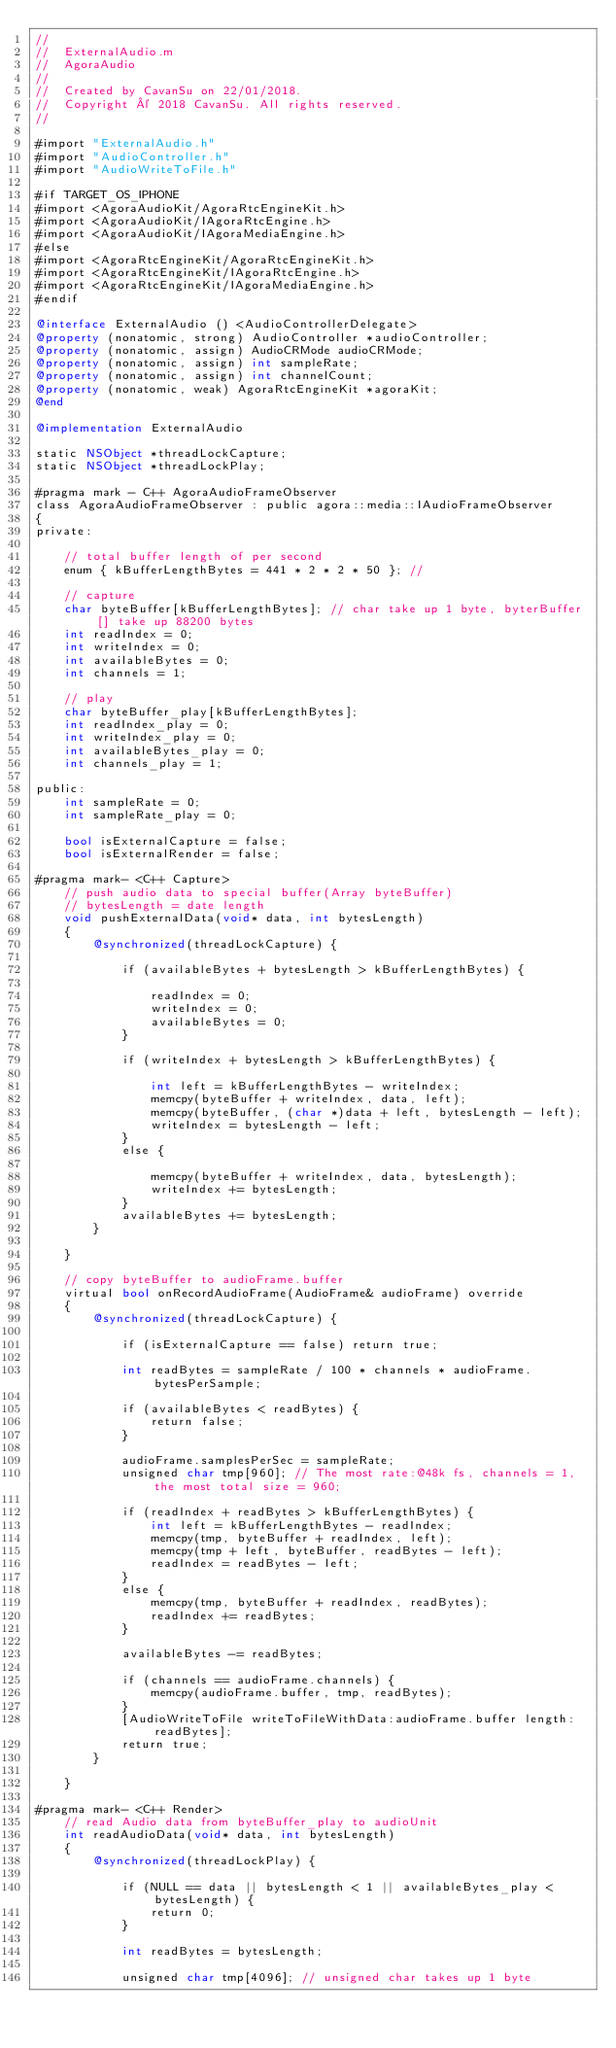Convert code to text. <code><loc_0><loc_0><loc_500><loc_500><_ObjectiveC_>//
//  ExternalAudio.m
//  AgoraAudio
//
//  Created by CavanSu on 22/01/2018.
//  Copyright © 2018 CavanSu. All rights reserved.
//

#import "ExternalAudio.h"
#import "AudioController.h"
#import "AudioWriteToFile.h"

#if TARGET_OS_IPHONE
#import <AgoraAudioKit/AgoraRtcEngineKit.h>
#import <AgoraAudioKit/IAgoraRtcEngine.h>
#import <AgoraAudioKit/IAgoraMediaEngine.h>
#else
#import <AgoraRtcEngineKit/AgoraRtcEngineKit.h>
#import <AgoraRtcEngineKit/IAgoraRtcEngine.h>
#import <AgoraRtcEngineKit/IAgoraMediaEngine.h>
#endif

@interface ExternalAudio () <AudioControllerDelegate>
@property (nonatomic, strong) AudioController *audioController;
@property (nonatomic, assign) AudioCRMode audioCRMode;
@property (nonatomic, assign) int sampleRate;
@property (nonatomic, assign) int channelCount;
@property (nonatomic, weak) AgoraRtcEngineKit *agoraKit;
@end

@implementation ExternalAudio

static NSObject *threadLockCapture;
static NSObject *threadLockPlay;

#pragma mark - C++ AgoraAudioFrameObserver
class AgoraAudioFrameObserver : public agora::media::IAudioFrameObserver
{
private:
    
    // total buffer length of per second
    enum { kBufferLengthBytes = 441 * 2 * 2 * 50 }; //
    
    // capture
    char byteBuffer[kBufferLengthBytes]; // char take up 1 byte, byterBuffer[] take up 88200 bytes
    int readIndex = 0;
    int writeIndex = 0;
    int availableBytes = 0;
    int channels = 1;
    
    // play
    char byteBuffer_play[kBufferLengthBytes];
    int readIndex_play = 0;
    int writeIndex_play = 0;
    int availableBytes_play = 0;
    int channels_play = 1;
    
public:
    int sampleRate = 0;
    int sampleRate_play = 0;
    
    bool isExternalCapture = false;
    bool isExternalRender = false;
    
#pragma mark- <C++ Capture>
    // push audio data to special buffer(Array byteBuffer)
    // bytesLength = date length
    void pushExternalData(void* data, int bytesLength)
    {
        @synchronized(threadLockCapture) {
            
            if (availableBytes + bytesLength > kBufferLengthBytes) {
                
                readIndex = 0;
                writeIndex = 0;
                availableBytes = 0;
            }
            
            if (writeIndex + bytesLength > kBufferLengthBytes) {
                
                int left = kBufferLengthBytes - writeIndex;
                memcpy(byteBuffer + writeIndex, data, left);
                memcpy(byteBuffer, (char *)data + left, bytesLength - left);
                writeIndex = bytesLength - left;
            }
            else {
                
                memcpy(byteBuffer + writeIndex, data, bytesLength);
                writeIndex += bytesLength;
            }
            availableBytes += bytesLength;
        }
    
    }
    
    // copy byteBuffer to audioFrame.buffer
    virtual bool onRecordAudioFrame(AudioFrame& audioFrame) override
    {
        @synchronized(threadLockCapture) {
            
            if (isExternalCapture == false) return true;
            
            int readBytes = sampleRate / 100 * channels * audioFrame.bytesPerSample;
            
            if (availableBytes < readBytes) {
                return false;
            }
            
            audioFrame.samplesPerSec = sampleRate;
            unsigned char tmp[960]; // The most rate:@48k fs, channels = 1, the most total size = 960;
            
            if (readIndex + readBytes > kBufferLengthBytes) {
                int left = kBufferLengthBytes - readIndex;
                memcpy(tmp, byteBuffer + readIndex, left);
                memcpy(tmp + left, byteBuffer, readBytes - left);
                readIndex = readBytes - left;
            }
            else {
                memcpy(tmp, byteBuffer + readIndex, readBytes);
                readIndex += readBytes;
            }
            
            availableBytes -= readBytes;
            
            if (channels == audioFrame.channels) {
                memcpy(audioFrame.buffer, tmp, readBytes);
            }
            [AudioWriteToFile writeToFileWithData:audioFrame.buffer length:readBytes];
            return true;
        }
        
    }
    
#pragma mark- <C++ Render>
    // read Audio data from byteBuffer_play to audioUnit
    int readAudioData(void* data, int bytesLength)
    {
        @synchronized(threadLockPlay) {
            
            if (NULL == data || bytesLength < 1 || availableBytes_play < bytesLength) {
                return 0;
            }
            
            int readBytes = bytesLength;
            
            unsigned char tmp[4096]; // unsigned char takes up 1 byte
            </code> 